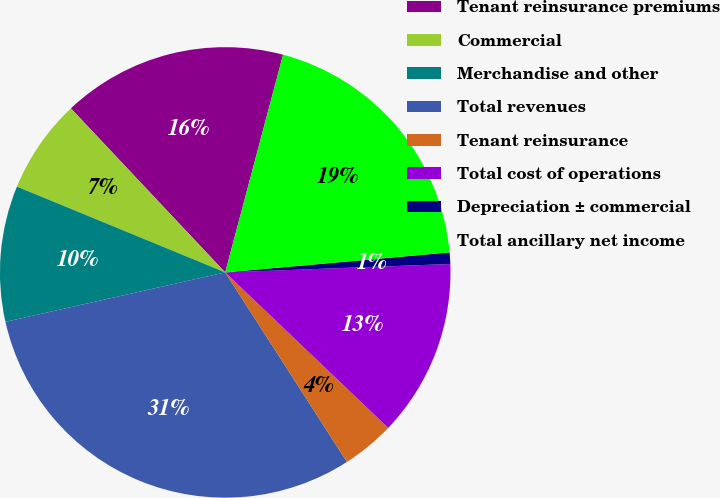Convert chart to OTSL. <chart><loc_0><loc_0><loc_500><loc_500><pie_chart><fcel>Tenant reinsurance premiums<fcel>Commercial<fcel>Merchandise and other<fcel>Total revenues<fcel>Tenant reinsurance<fcel>Total cost of operations<fcel>Depreciation ± commercial<fcel>Total ancillary net income<nl><fcel>16.15%<fcel>6.77%<fcel>9.74%<fcel>30.57%<fcel>3.79%<fcel>12.72%<fcel>0.82%<fcel>19.45%<nl></chart> 